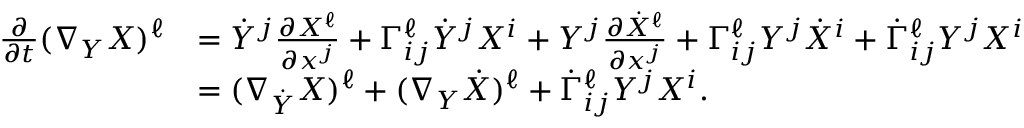<formula> <loc_0><loc_0><loc_500><loc_500>\begin{array} { r l } { \frac { \partial } { \partial t } ( \nabla _ { Y } X ) ^ { \ell } } & { = \dot { Y } ^ { j } \frac { \partial X ^ { \ell } } { \partial x ^ { j } } + \Gamma _ { i j } ^ { \ell } \dot { Y } ^ { j } X ^ { i } + Y ^ { j } \frac { \partial \dot { X } ^ { \ell } } { \partial x ^ { j } } + \Gamma _ { i j } ^ { \ell } Y ^ { j } \dot { X } ^ { i } + \dot { \Gamma } _ { i j } ^ { \ell } Y ^ { j } X ^ { i } } \\ & { = ( \nabla _ { \dot { Y } } X ) ^ { \ell } + ( \nabla _ { Y } \dot { X } ) ^ { \ell } + \dot { \Gamma } _ { i j } ^ { \ell } Y ^ { j } X ^ { i } . } \end{array}</formula> 